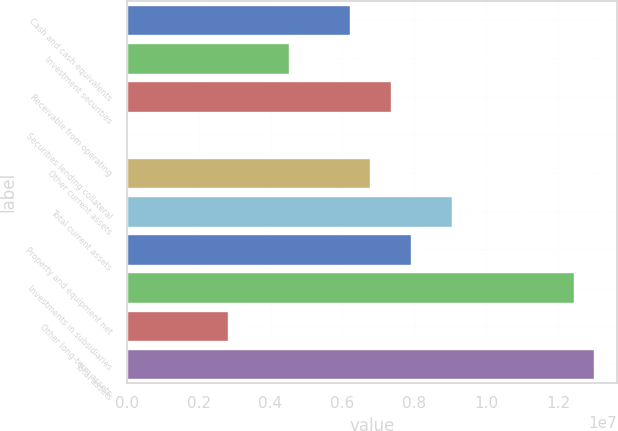Convert chart. <chart><loc_0><loc_0><loc_500><loc_500><bar_chart><fcel>Cash and cash equivalents<fcel>Investment securities<fcel>Receivable from operating<fcel>Securities lending collateral<fcel>Other current assets<fcel>Total current assets<fcel>Property and equipment net<fcel>Investments in subsidiaries<fcel>Other long-term assets<fcel>Total assets<nl><fcel>6.21568e+06<fcel>4.52079e+06<fcel>7.34561e+06<fcel>1081<fcel>6.78065e+06<fcel>9.0405e+06<fcel>7.91057e+06<fcel>1.24303e+07<fcel>2.8259e+06<fcel>1.29952e+07<nl></chart> 